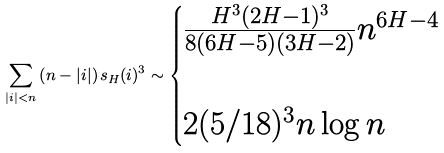<formula> <loc_0><loc_0><loc_500><loc_500>\sum _ { | i | < n } \left ( n - | i | \right ) s _ { H } ( i ) ^ { 3 } \sim \begin{cases} \frac { H ^ { 3 } ( 2 H - 1 ) ^ { 3 } } { 8 ( 6 H - 5 ) ( 3 H - 2 ) } n ^ { 6 H - 4 } & \\ \quad \\ 2 ( 5 / 1 8 ) ^ { 3 } n \log n & \end{cases}</formula> 